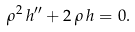Convert formula to latex. <formula><loc_0><loc_0><loc_500><loc_500>\rho ^ { 2 } \, h ^ { \prime \prime } + 2 \, \rho \, h = 0 .</formula> 